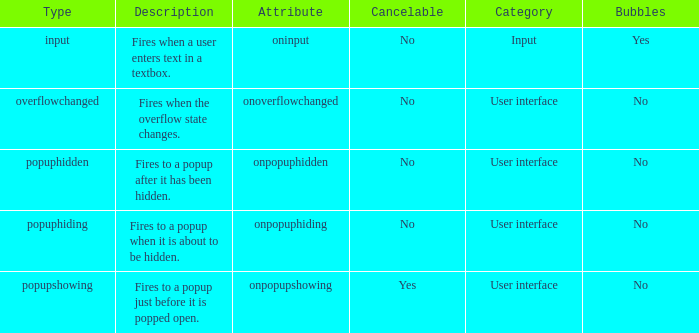Can you parse all the data within this table? {'header': ['Type', 'Description', 'Attribute', 'Cancelable', 'Category', 'Bubbles'], 'rows': [['input', 'Fires when a user enters text in a textbox.', 'oninput', 'No', 'Input', 'Yes'], ['overflowchanged', 'Fires when the overflow state changes.', 'onoverflowchanged', 'No', 'User interface', 'No'], ['popuphidden', 'Fires to a popup after it has been hidden.', 'onpopuphidden', 'No', 'User interface', 'No'], ['popuphiding', 'Fires to a popup when it is about to be hidden.', 'onpopuphiding', 'No', 'User interface', 'No'], ['popupshowing', 'Fires to a popup just before it is popped open.', 'onpopupshowing', 'Yes', 'User interface', 'No']]} What's the type with description being fires when the overflow state changes. Overflowchanged. 